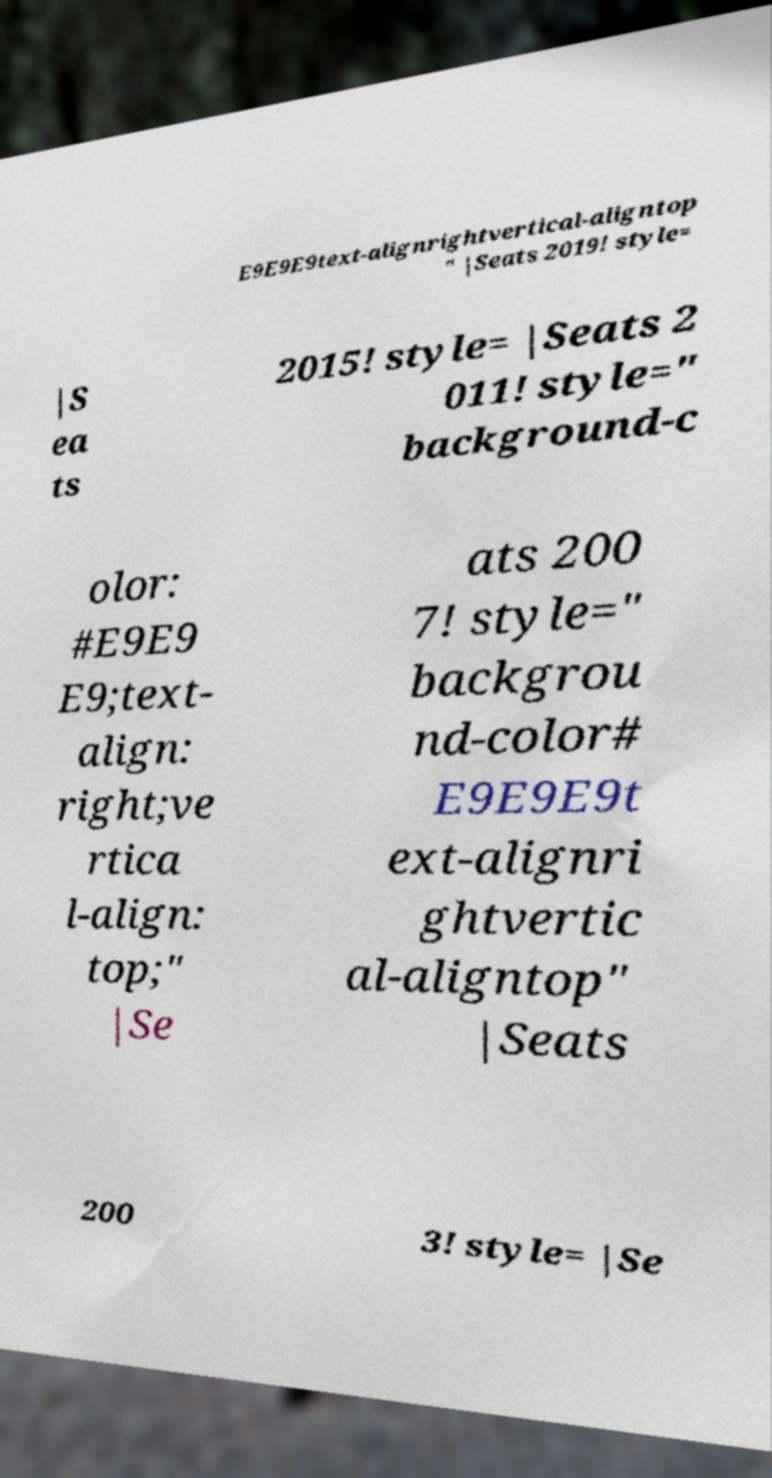I need the written content from this picture converted into text. Can you do that? E9E9E9text-alignrightvertical-aligntop " |Seats 2019! style= |S ea ts 2015! style= |Seats 2 011! style=" background-c olor: #E9E9 E9;text- align: right;ve rtica l-align: top;" |Se ats 200 7! style=" backgrou nd-color# E9E9E9t ext-alignri ghtvertic al-aligntop" |Seats 200 3! style= |Se 